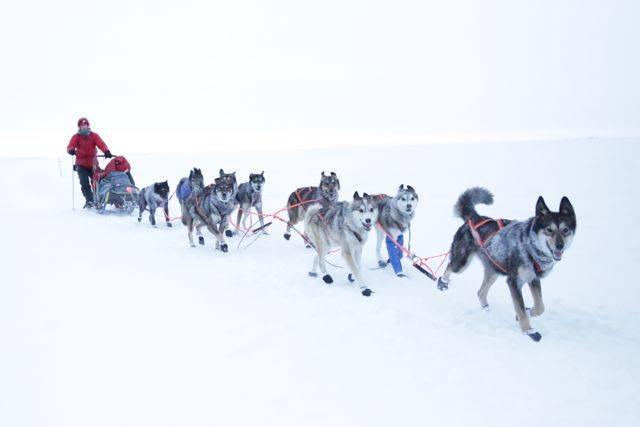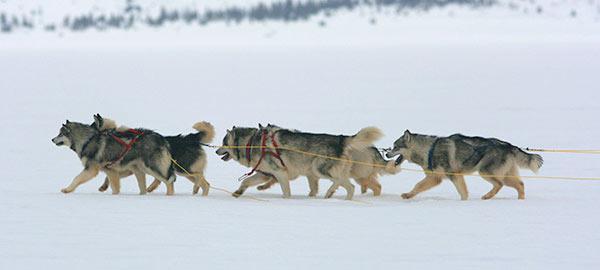The first image is the image on the left, the second image is the image on the right. Analyze the images presented: Is the assertion "The left image contains exactly one dog." valid? Answer yes or no. No. The first image is the image on the left, the second image is the image on the right. Analyze the images presented: Is the assertion "An image shows a multicolored dog wearing a red harness that extends out of the snowy scene." valid? Answer yes or no. No. 